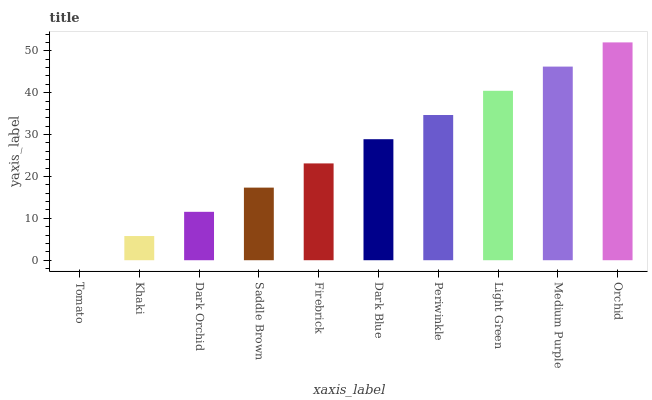Is Khaki the minimum?
Answer yes or no. No. Is Khaki the maximum?
Answer yes or no. No. Is Khaki greater than Tomato?
Answer yes or no. Yes. Is Tomato less than Khaki?
Answer yes or no. Yes. Is Tomato greater than Khaki?
Answer yes or no. No. Is Khaki less than Tomato?
Answer yes or no. No. Is Dark Blue the high median?
Answer yes or no. Yes. Is Firebrick the low median?
Answer yes or no. Yes. Is Orchid the high median?
Answer yes or no. No. Is Dark Orchid the low median?
Answer yes or no. No. 